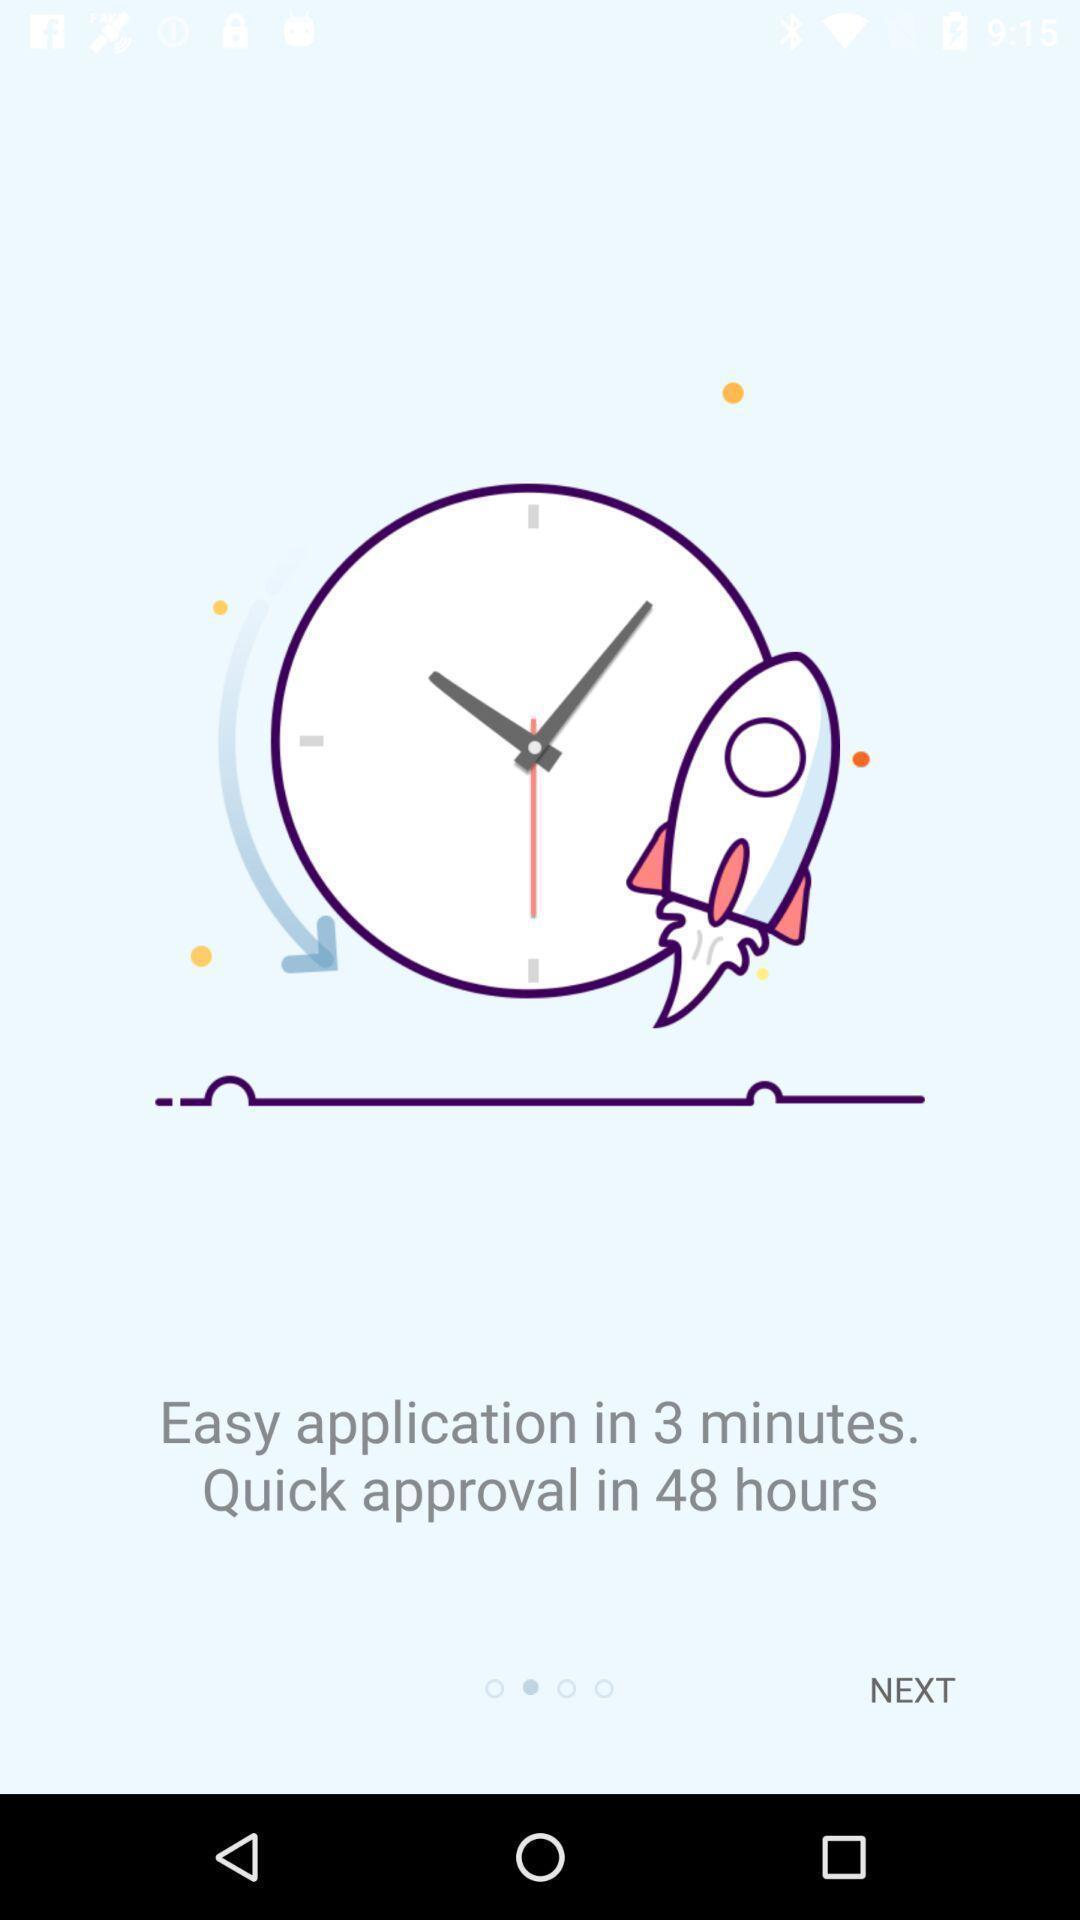Summarize the main components in this picture. Starting page. 